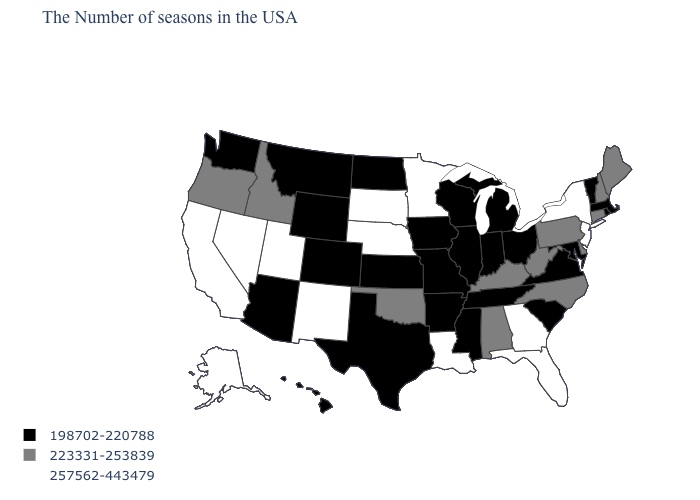What is the value of Colorado?
Short answer required. 198702-220788. Which states hav the highest value in the West?
Write a very short answer. New Mexico, Utah, Nevada, California, Alaska. Does the map have missing data?
Give a very brief answer. No. Name the states that have a value in the range 198702-220788?
Quick response, please. Massachusetts, Rhode Island, Vermont, Maryland, Virginia, South Carolina, Ohio, Michigan, Indiana, Tennessee, Wisconsin, Illinois, Mississippi, Missouri, Arkansas, Iowa, Kansas, Texas, North Dakota, Wyoming, Colorado, Montana, Arizona, Washington, Hawaii. What is the value of New Jersey?
Answer briefly. 257562-443479. Which states have the lowest value in the South?
Quick response, please. Maryland, Virginia, South Carolina, Tennessee, Mississippi, Arkansas, Texas. Among the states that border South Carolina , which have the highest value?
Short answer required. Georgia. Which states have the lowest value in the USA?
Give a very brief answer. Massachusetts, Rhode Island, Vermont, Maryland, Virginia, South Carolina, Ohio, Michigan, Indiana, Tennessee, Wisconsin, Illinois, Mississippi, Missouri, Arkansas, Iowa, Kansas, Texas, North Dakota, Wyoming, Colorado, Montana, Arizona, Washington, Hawaii. Does Georgia have a higher value than Massachusetts?
Write a very short answer. Yes. Which states hav the highest value in the West?
Short answer required. New Mexico, Utah, Nevada, California, Alaska. What is the lowest value in the USA?
Give a very brief answer. 198702-220788. Which states have the lowest value in the USA?
Keep it brief. Massachusetts, Rhode Island, Vermont, Maryland, Virginia, South Carolina, Ohio, Michigan, Indiana, Tennessee, Wisconsin, Illinois, Mississippi, Missouri, Arkansas, Iowa, Kansas, Texas, North Dakota, Wyoming, Colorado, Montana, Arizona, Washington, Hawaii. Does the first symbol in the legend represent the smallest category?
Short answer required. Yes. Name the states that have a value in the range 223331-253839?
Give a very brief answer. Maine, New Hampshire, Connecticut, Delaware, Pennsylvania, North Carolina, West Virginia, Kentucky, Alabama, Oklahoma, Idaho, Oregon. Name the states that have a value in the range 257562-443479?
Answer briefly. New York, New Jersey, Florida, Georgia, Louisiana, Minnesota, Nebraska, South Dakota, New Mexico, Utah, Nevada, California, Alaska. 